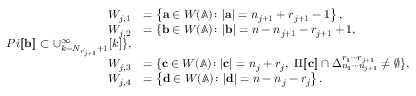<formula> <loc_0><loc_0><loc_500><loc_500>\begin{array} { r l } { W _ { j , 1 } } & { = \left \{ \mathbf a \in W ( \mathbb { A } ) \colon | \mathbf a | = n _ { j + 1 } + r _ { j + 1 } - 1 \right \} , } \\ { W _ { j , 2 } } & { = \{ \mathbf b \in W ( \mathbb { A } ) \colon | \mathbf b | = n - n _ { j + 1 } - r _ { j + 1 } + 1 , } \\ { P i [ \, [ \mathbf b ] \, ] \subset \cup _ { k = N _ { r _ { j + 1 } } + 1 } ^ { \infty } [ k ] \} , } \\ { W _ { j , 3 } } & { = \{ \mathbf c \in W ( \mathbb { A } ) \colon | \mathbf c | = n _ { j } + r _ { j } , \ \Pi [ \, [ \mathbf c ] \, ] \cap \Delta _ { n _ { 1 } \cdots n _ { j + 1 } } ^ { r _ { 1 } \cdots r _ { j + 1 } } \neq \emptyset \} , } \\ { W _ { j , 4 } } & { = \left \{ \mathbf d \in W ( \mathbb { A } ) \colon | \mathbf d | = n - n _ { j } - r _ { j } \right \} . } \end{array}</formula> 